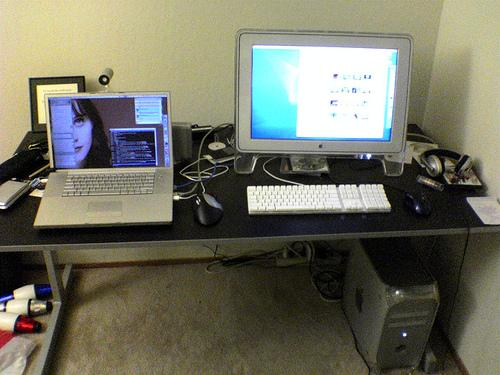How many computer displays are on top of the black desk with two mouses? two 